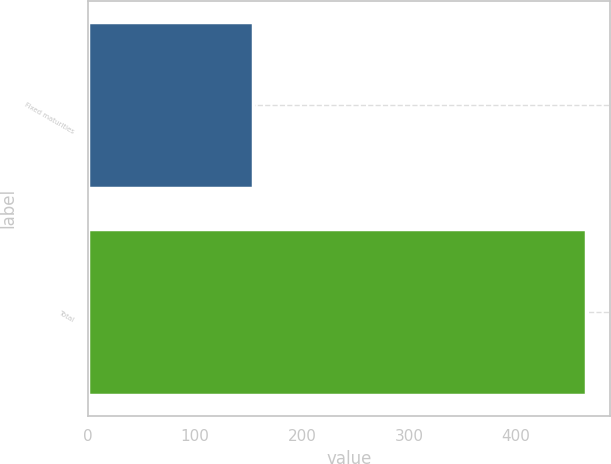<chart> <loc_0><loc_0><loc_500><loc_500><bar_chart><fcel>Fixed maturities<fcel>Total<nl><fcel>154<fcel>465<nl></chart> 